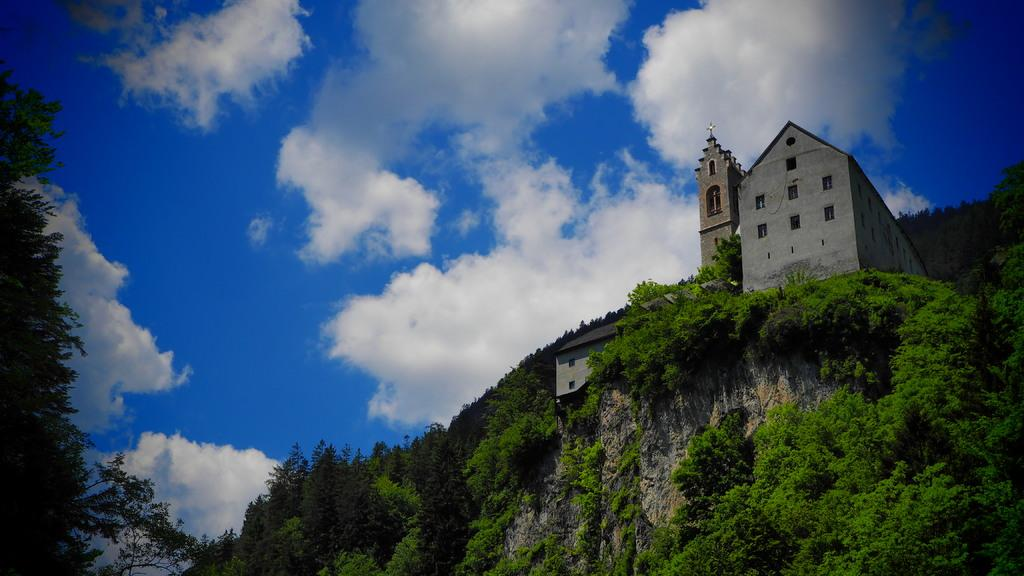What type of structure can be seen in the image? There is a building and a church in the image. Where are the building and church located? Both the building and church are located on a mountain. What can be seen at the top of the image? The sky is visible at the top of the image, and clouds are present in the sky. What type of vegetation is visible at the bottom of the image? There are many trees visible at the bottom of the image. What type of toy is being played with by the clouds in the image? There are no toys present in the image, and the clouds are not playing with any objects. 